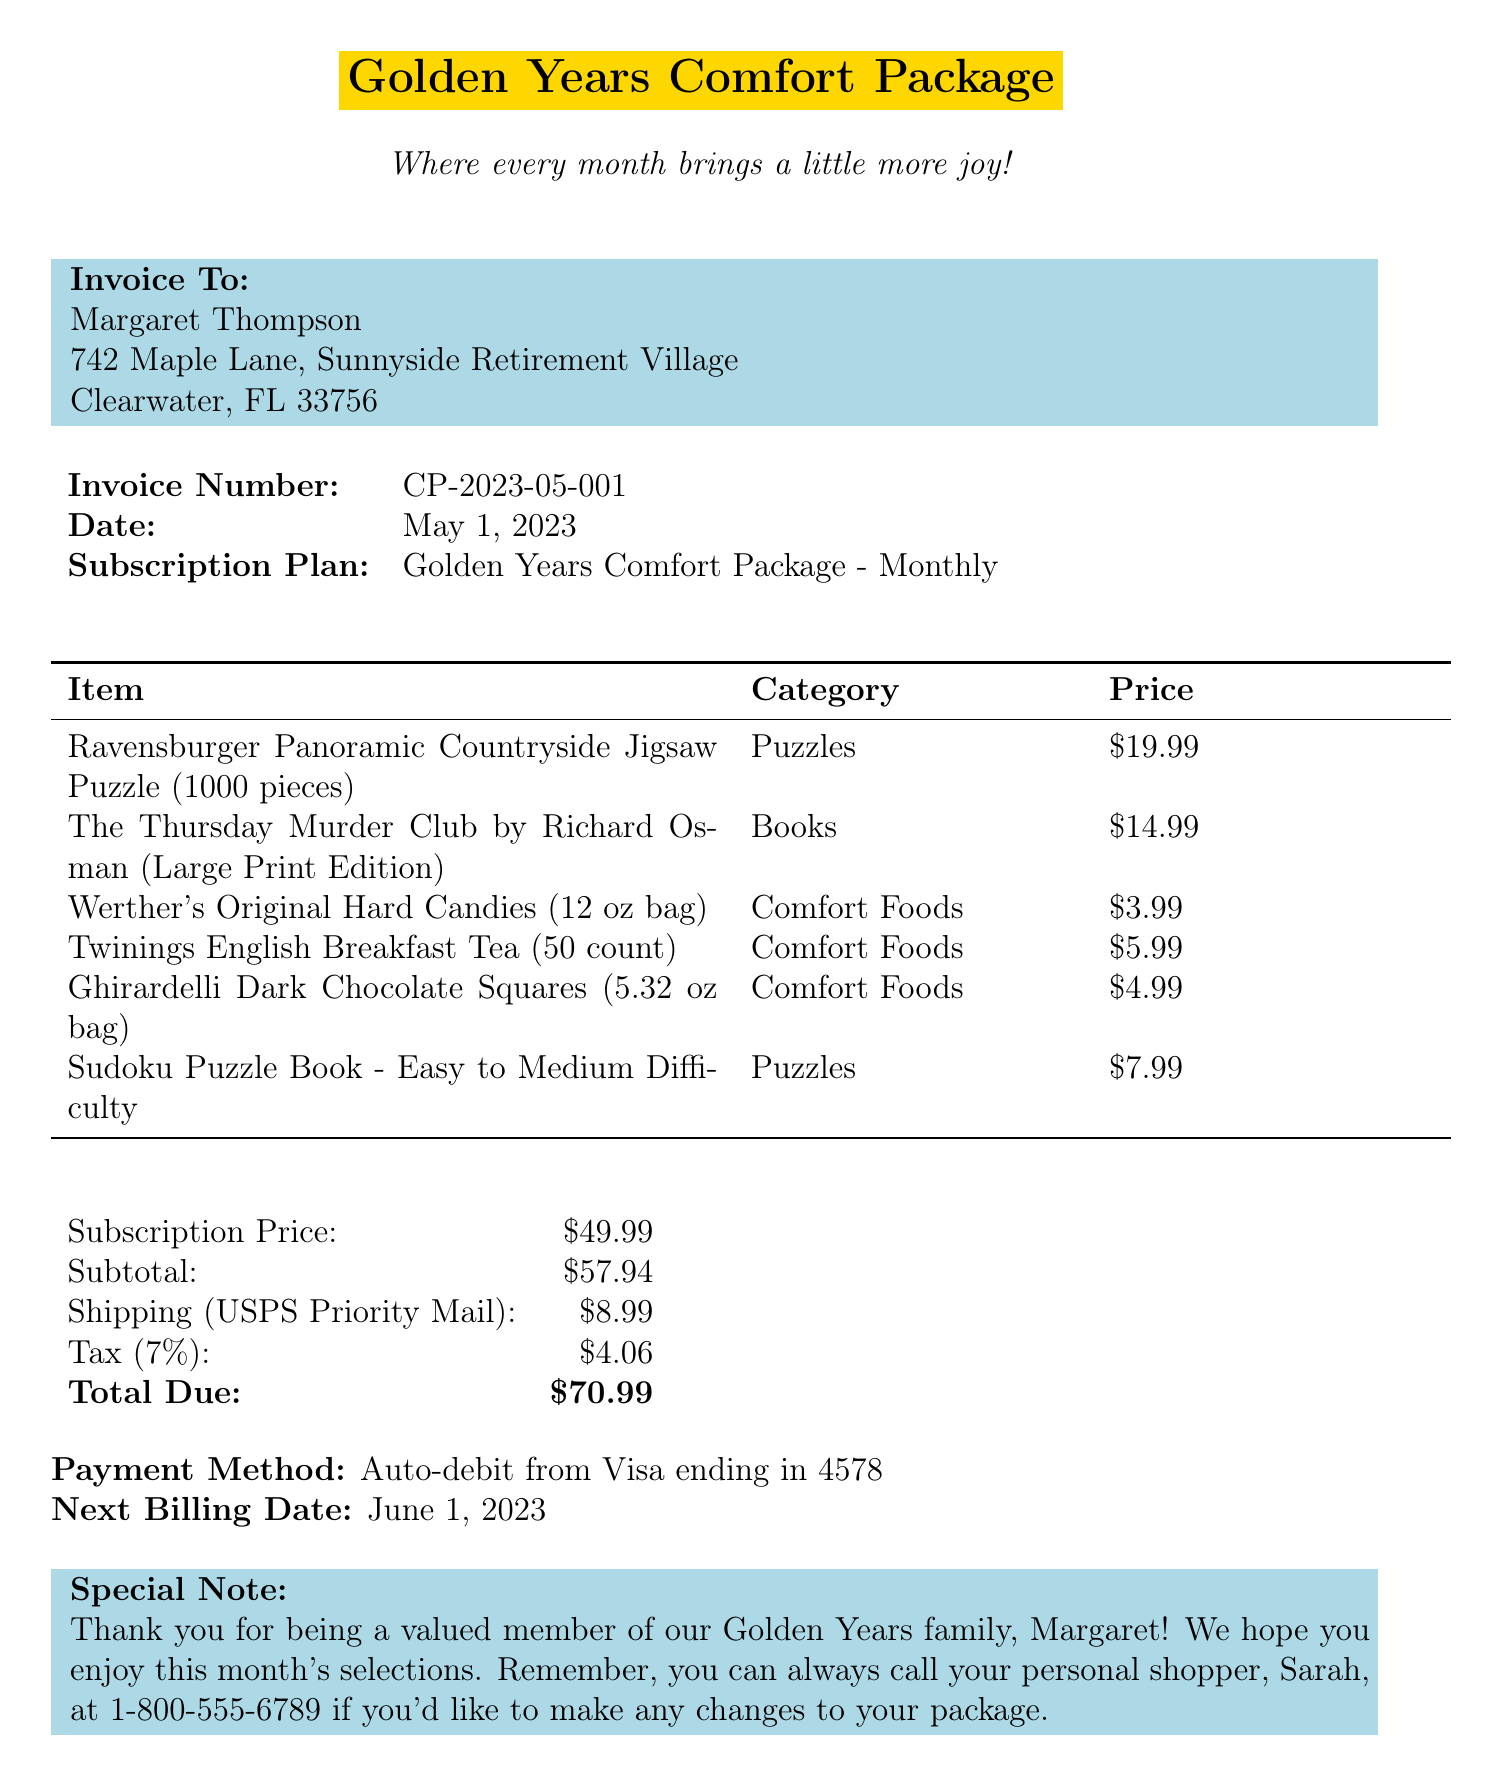What is the invoice number? The invoice number is a unique identifier for this billing statement provided in the document.
Answer: CP-2023-05-001 What is the subscription price? The subscription price is the cost associated with the monthly care package service as stated in the document.
Answer: $49.99 What is the total due amount? The total due is the final amount payable after calculating all charges, including tax and shipping, presented in the document.
Answer: $70.99 Who is the customer? The customer's name appears at the top of the invoice and indicates who the billing statement is for.
Answer: Margaret Thompson When is the next billing date? The next billing date indicates when the customer's subscription will be charged again, noted in the document.
Answer: June 1, 2023 What items are included in the package? This question references the list of products under the items section in the document, asking for the types of products provided in the care package.
Answer: Puzzles, Books, Comfort Foods What is the shipping method used? The shipping method describes how the items will be delivered to the customer, as specified in the document.
Answer: USPS Priority Mail What is the tax rate applied? The tax rate used to calculate the tax amount on the subtotal is presented in the invoice.
Answer: 7% What is the special note addressed to the customer? The special note includes personal remarks and information for the customer as indicated in the document.
Answer: Thank you for being a valued member of our Golden Years family, Margaret! We hope you enjoy this month's selections 